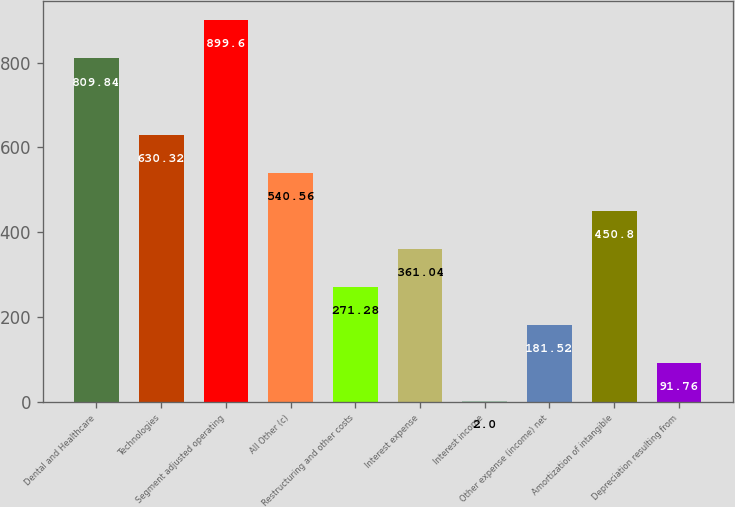Convert chart to OTSL. <chart><loc_0><loc_0><loc_500><loc_500><bar_chart><fcel>Dental and Healthcare<fcel>Technologies<fcel>Segment adjusted operating<fcel>All Other (c)<fcel>Restructuring and other costs<fcel>Interest expense<fcel>Interest income<fcel>Other expense (income) net<fcel>Amortization of intangible<fcel>Depreciation resulting from<nl><fcel>809.84<fcel>630.32<fcel>899.6<fcel>540.56<fcel>271.28<fcel>361.04<fcel>2<fcel>181.52<fcel>450.8<fcel>91.76<nl></chart> 